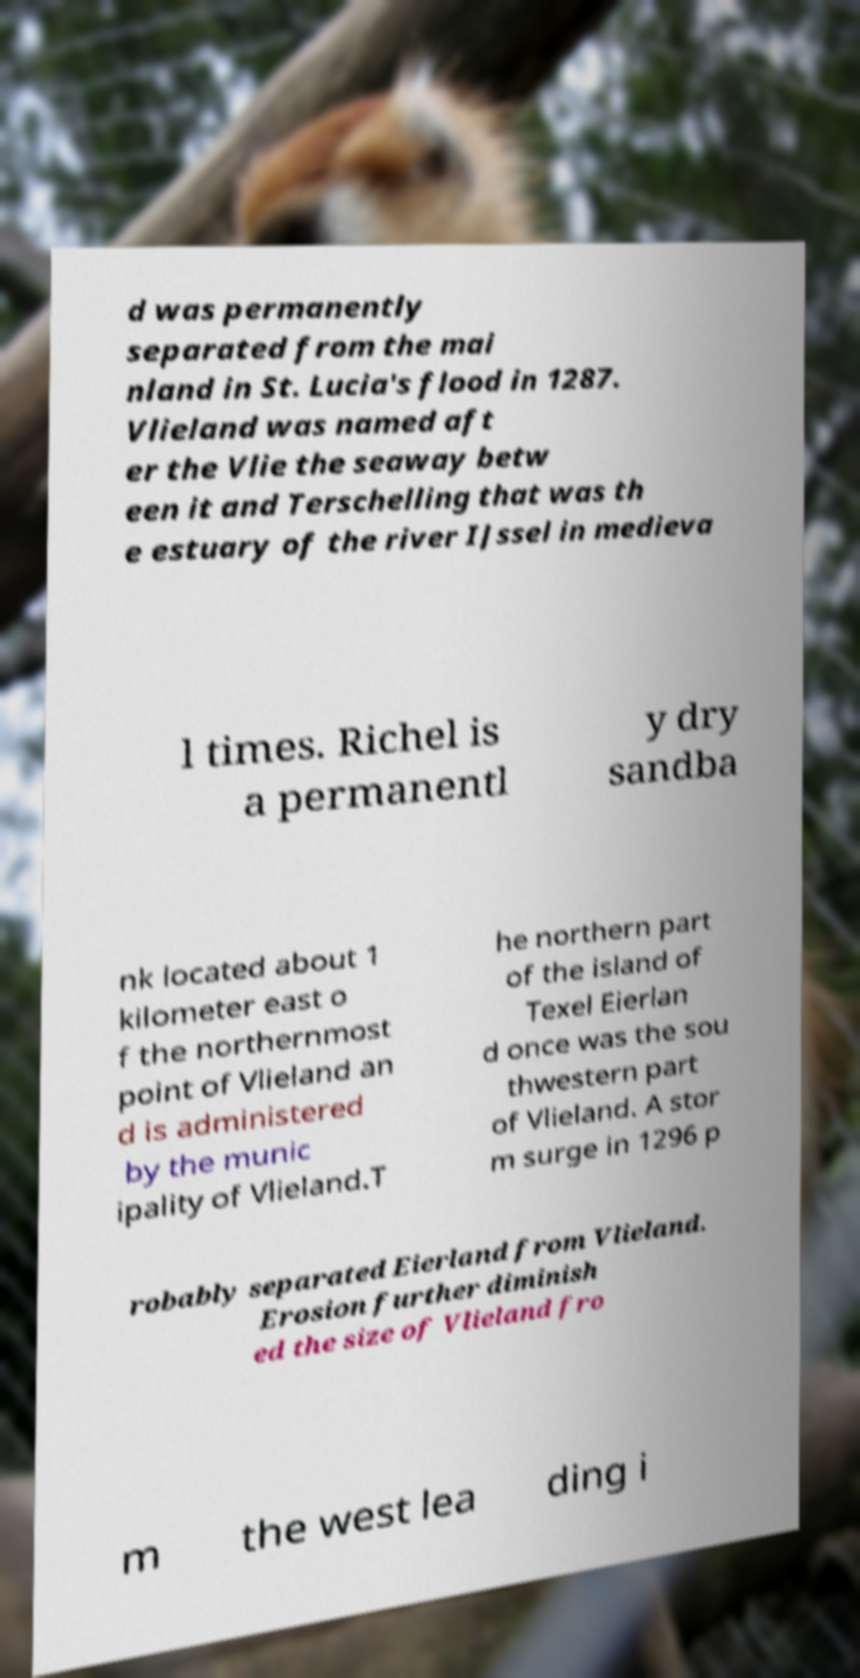Please identify and transcribe the text found in this image. d was permanently separated from the mai nland in St. Lucia's flood in 1287. Vlieland was named aft er the Vlie the seaway betw een it and Terschelling that was th e estuary of the river IJssel in medieva l times. Richel is a permanentl y dry sandba nk located about 1 kilometer east o f the northernmost point of Vlieland an d is administered by the munic ipality of Vlieland.T he northern part of the island of Texel Eierlan d once was the sou thwestern part of Vlieland. A stor m surge in 1296 p robably separated Eierland from Vlieland. Erosion further diminish ed the size of Vlieland fro m the west lea ding i 